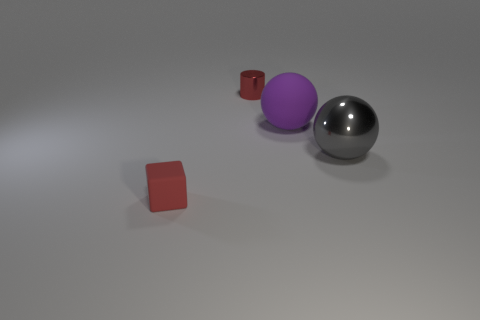What color is the large object that is to the right of the purple matte sphere? The large object to the right of the purple matte sphere is a shiny, metallic gray sphere that reflects light and surrounding colors, giving it a realistic appearance of a chrome finish. 